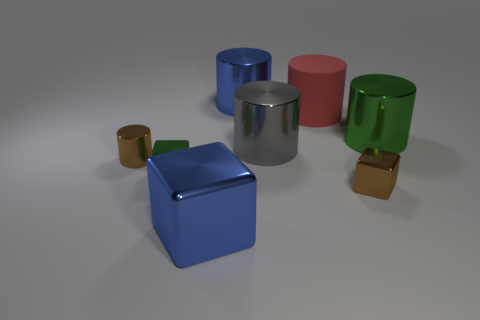Subtract 2 cylinders. How many cylinders are left? 3 Subtract all gray cylinders. How many cylinders are left? 4 Subtract all red cylinders. How many cylinders are left? 4 Subtract all purple cylinders. Subtract all yellow spheres. How many cylinders are left? 5 Add 1 small purple rubber cubes. How many objects exist? 9 Subtract all cylinders. How many objects are left? 3 Subtract 0 gray spheres. How many objects are left? 8 Subtract all big red rubber things. Subtract all red matte cylinders. How many objects are left? 6 Add 6 green objects. How many green objects are left? 8 Add 8 big red metallic cubes. How many big red metallic cubes exist? 8 